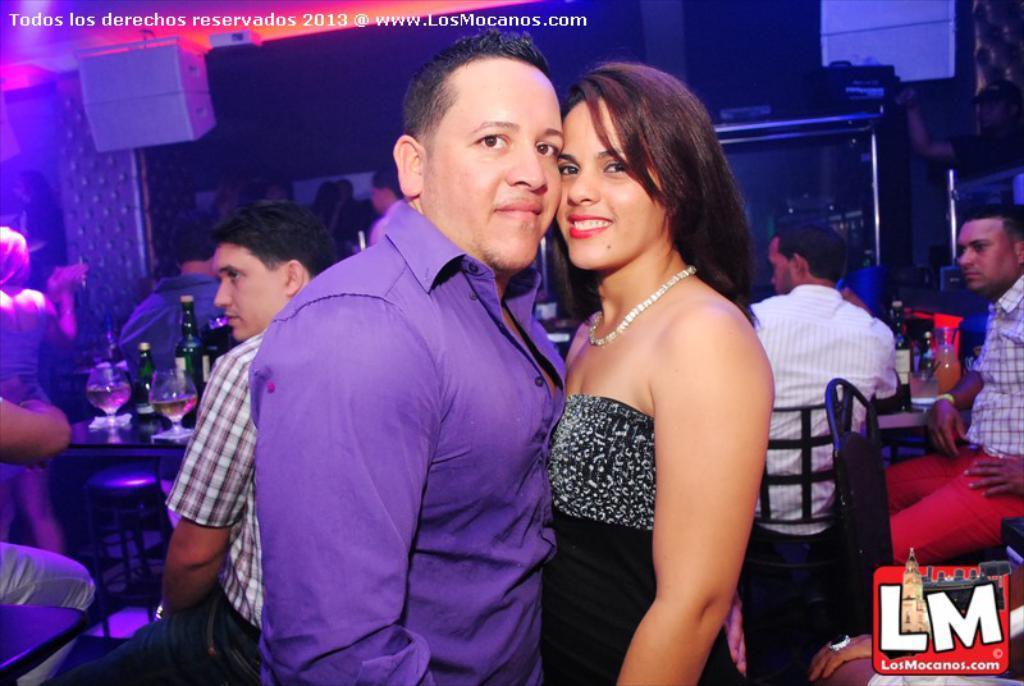Can you describe this image briefly? In this image I can see number of people where few are standing and few are sitting on chairs. In the centre of the image I can see few tables and on it I can see few glasses, few bottles and few other things. In the background I can see few speakers, few black colour things and other stuffs. I can see watermarks on the top left side and on the bottom right side of the image. 